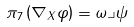Convert formula to latex. <formula><loc_0><loc_0><loc_500><loc_500>\pi _ { 7 } \left ( \nabla _ { X } \varphi \right ) = \omega \lrcorner \psi</formula> 